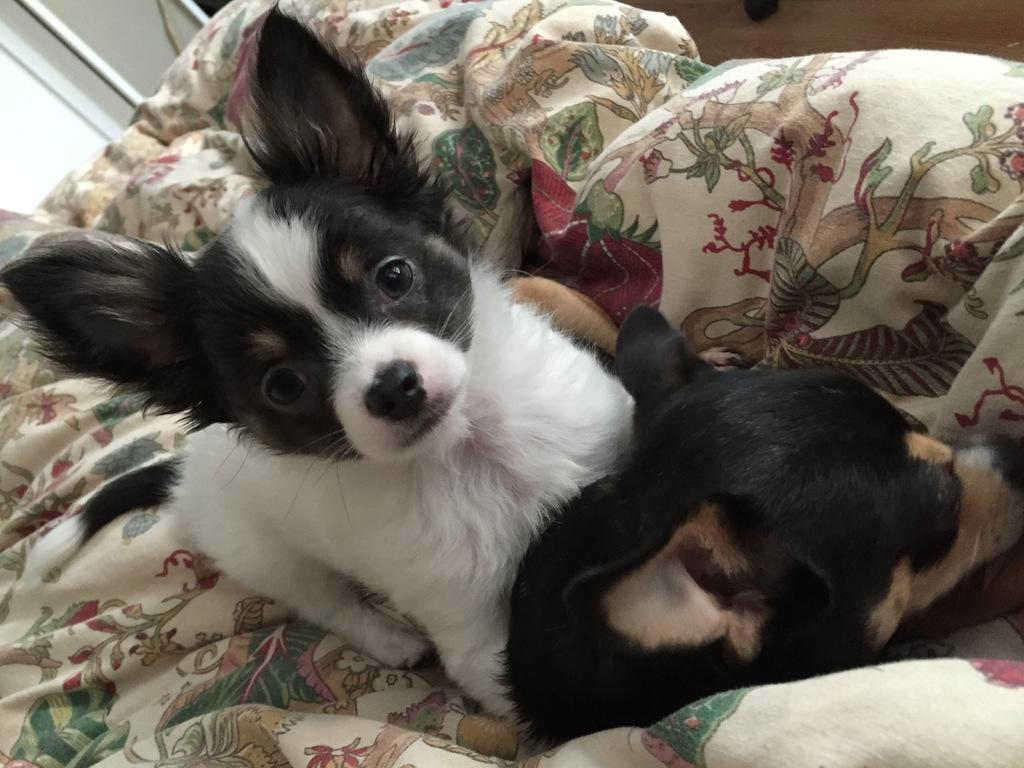How many dogs are present in the image? There are two dogs in the image. What surface are the dogs on? The dogs are on a cloth. Can you describe the cloth in the image? The cloth has designs on it. What type of meal is being prepared on the cloth in the image? There is no meal being prepared in the image; it features two dogs on a cloth with designs. 